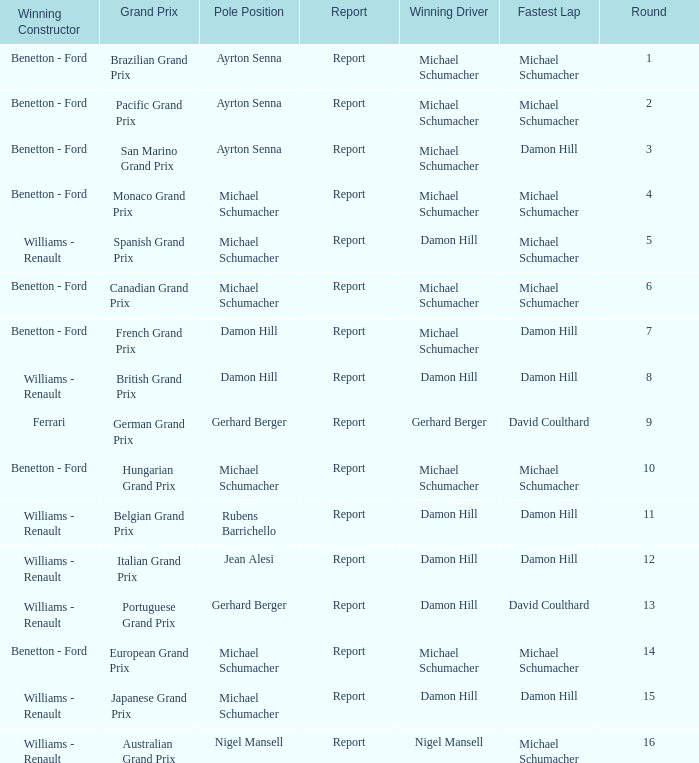Can you give me this table as a dict? {'header': ['Winning Constructor', 'Grand Prix', 'Pole Position', 'Report', 'Winning Driver', 'Fastest Lap', 'Round'], 'rows': [['Benetton - Ford', 'Brazilian Grand Prix', 'Ayrton Senna', 'Report', 'Michael Schumacher', 'Michael Schumacher', '1'], ['Benetton - Ford', 'Pacific Grand Prix', 'Ayrton Senna', 'Report', 'Michael Schumacher', 'Michael Schumacher', '2'], ['Benetton - Ford', 'San Marino Grand Prix', 'Ayrton Senna', 'Report', 'Michael Schumacher', 'Damon Hill', '3'], ['Benetton - Ford', 'Monaco Grand Prix', 'Michael Schumacher', 'Report', 'Michael Schumacher', 'Michael Schumacher', '4'], ['Williams - Renault', 'Spanish Grand Prix', 'Michael Schumacher', 'Report', 'Damon Hill', 'Michael Schumacher', '5'], ['Benetton - Ford', 'Canadian Grand Prix', 'Michael Schumacher', 'Report', 'Michael Schumacher', 'Michael Schumacher', '6'], ['Benetton - Ford', 'French Grand Prix', 'Damon Hill', 'Report', 'Michael Schumacher', 'Damon Hill', '7'], ['Williams - Renault', 'British Grand Prix', 'Damon Hill', 'Report', 'Damon Hill', 'Damon Hill', '8'], ['Ferrari', 'German Grand Prix', 'Gerhard Berger', 'Report', 'Gerhard Berger', 'David Coulthard', '9'], ['Benetton - Ford', 'Hungarian Grand Prix', 'Michael Schumacher', 'Report', 'Michael Schumacher', 'Michael Schumacher', '10'], ['Williams - Renault', 'Belgian Grand Prix', 'Rubens Barrichello', 'Report', 'Damon Hill', 'Damon Hill', '11'], ['Williams - Renault', 'Italian Grand Prix', 'Jean Alesi', 'Report', 'Damon Hill', 'Damon Hill', '12'], ['Williams - Renault', 'Portuguese Grand Prix', 'Gerhard Berger', 'Report', 'Damon Hill', 'David Coulthard', '13'], ['Benetton - Ford', 'European Grand Prix', 'Michael Schumacher', 'Report', 'Michael Schumacher', 'Michael Schumacher', '14'], ['Williams - Renault', 'Japanese Grand Prix', 'Michael Schumacher', 'Report', 'Damon Hill', 'Damon Hill', '15'], ['Williams - Renault', 'Australian Grand Prix', 'Nigel Mansell', 'Report', 'Nigel Mansell', 'Michael Schumacher', '16']]} Name the lowest round for when pole position and winning driver is michael schumacher 4.0. 